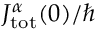Convert formula to latex. <formula><loc_0><loc_0><loc_500><loc_500>J _ { t o t } ^ { \alpha } ( 0 ) / \hbar</formula> 